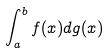Convert formula to latex. <formula><loc_0><loc_0><loc_500><loc_500>\int _ { a } ^ { b } f ( x ) d g ( x )</formula> 